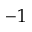<formula> <loc_0><loc_0><loc_500><loc_500>- 1</formula> 